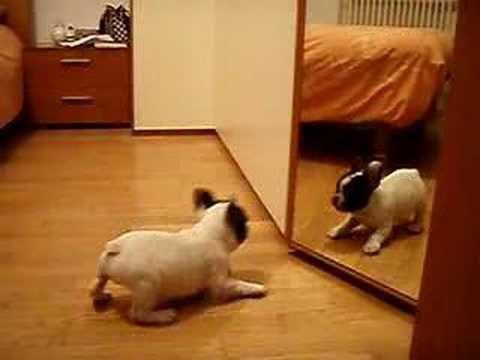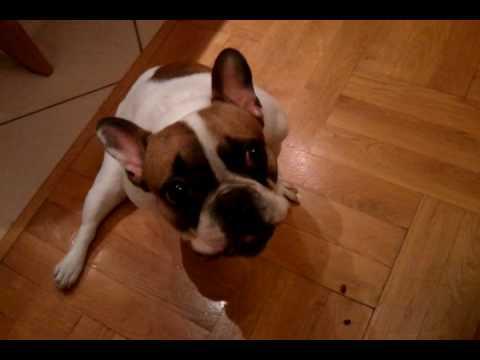The first image is the image on the left, the second image is the image on the right. Assess this claim about the two images: "A black-and-white faced dog is leaning back on its haunches and at least appears to face another animal.". Correct or not? Answer yes or no. Yes. 